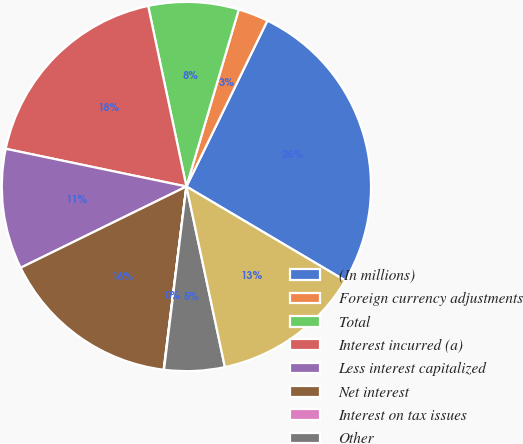Convert chart to OTSL. <chart><loc_0><loc_0><loc_500><loc_500><pie_chart><fcel>(In millions)<fcel>Foreign currency adjustments<fcel>Total<fcel>Interest incurred (a)<fcel>Less interest capitalized<fcel>Net interest<fcel>Interest on tax issues<fcel>Other<fcel>Net interest and other<nl><fcel>26.28%<fcel>2.65%<fcel>7.9%<fcel>18.4%<fcel>10.53%<fcel>15.78%<fcel>0.03%<fcel>5.28%<fcel>13.15%<nl></chart> 